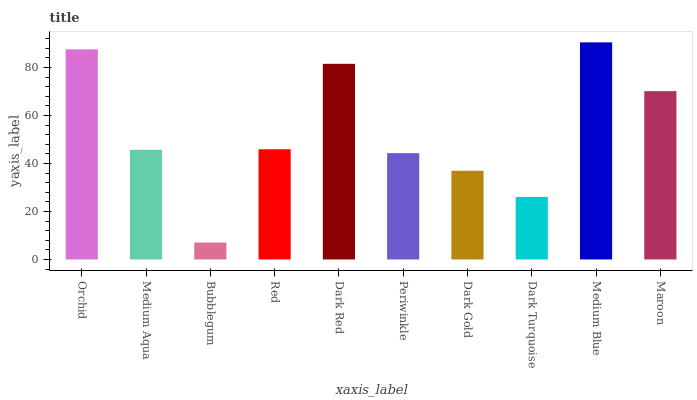Is Bubblegum the minimum?
Answer yes or no. Yes. Is Medium Blue the maximum?
Answer yes or no. Yes. Is Medium Aqua the minimum?
Answer yes or no. No. Is Medium Aqua the maximum?
Answer yes or no. No. Is Orchid greater than Medium Aqua?
Answer yes or no. Yes. Is Medium Aqua less than Orchid?
Answer yes or no. Yes. Is Medium Aqua greater than Orchid?
Answer yes or no. No. Is Orchid less than Medium Aqua?
Answer yes or no. No. Is Red the high median?
Answer yes or no. Yes. Is Medium Aqua the low median?
Answer yes or no. Yes. Is Orchid the high median?
Answer yes or no. No. Is Periwinkle the low median?
Answer yes or no. No. 